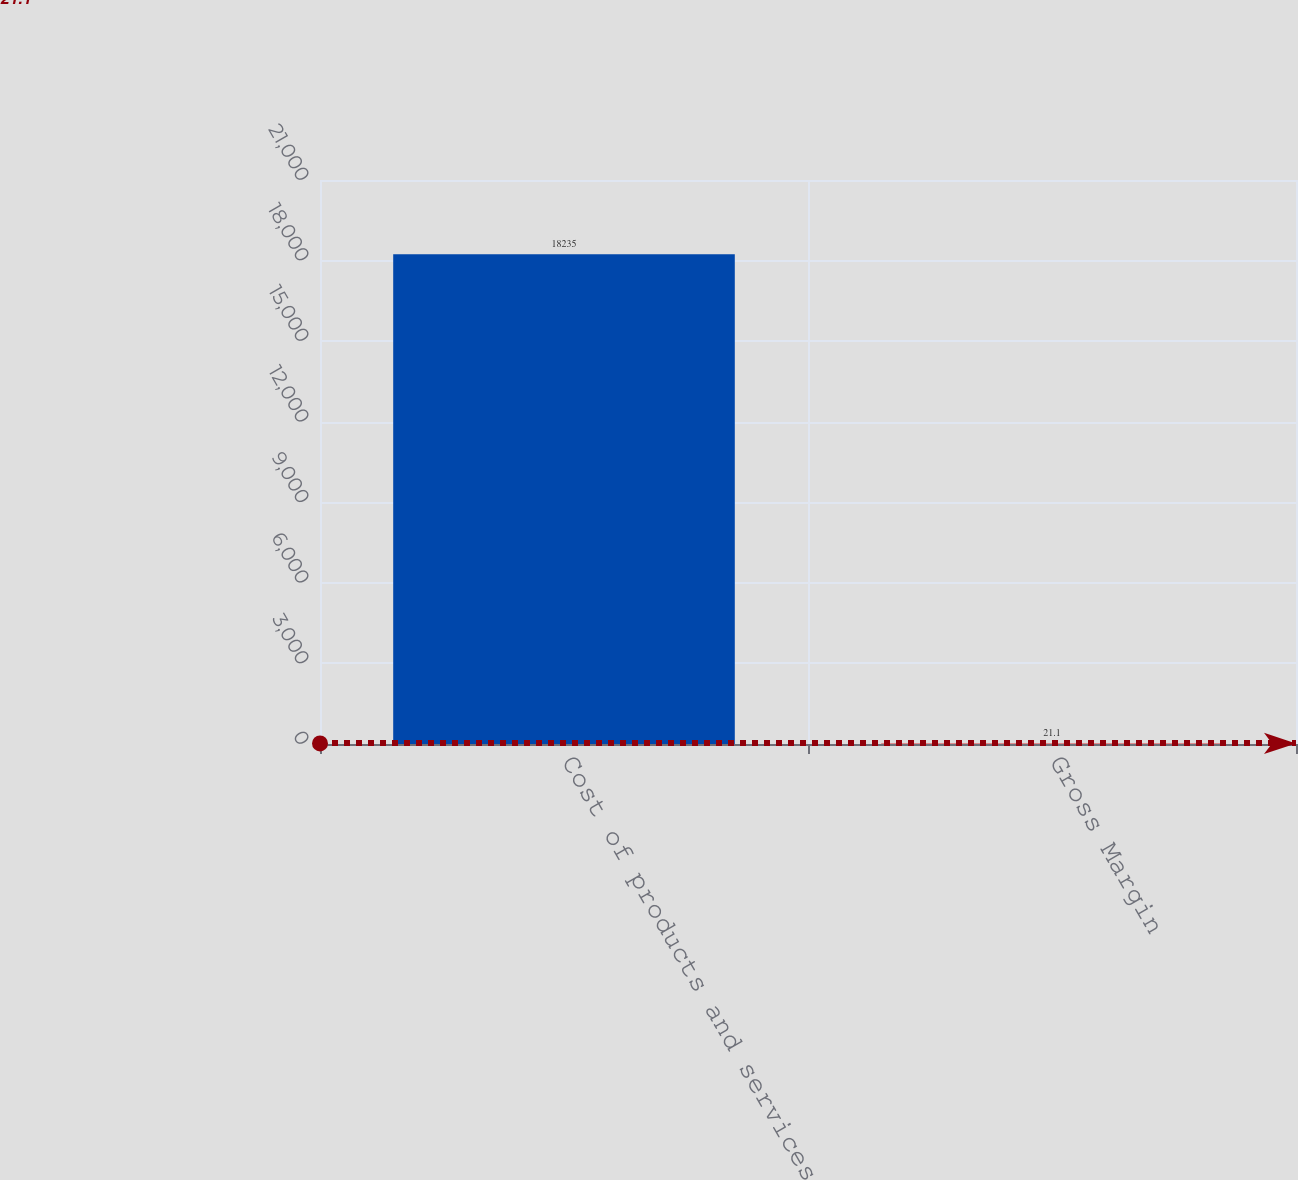<chart> <loc_0><loc_0><loc_500><loc_500><bar_chart><fcel>Cost of products and services<fcel>Gross Margin<nl><fcel>18235<fcel>21.1<nl></chart> 